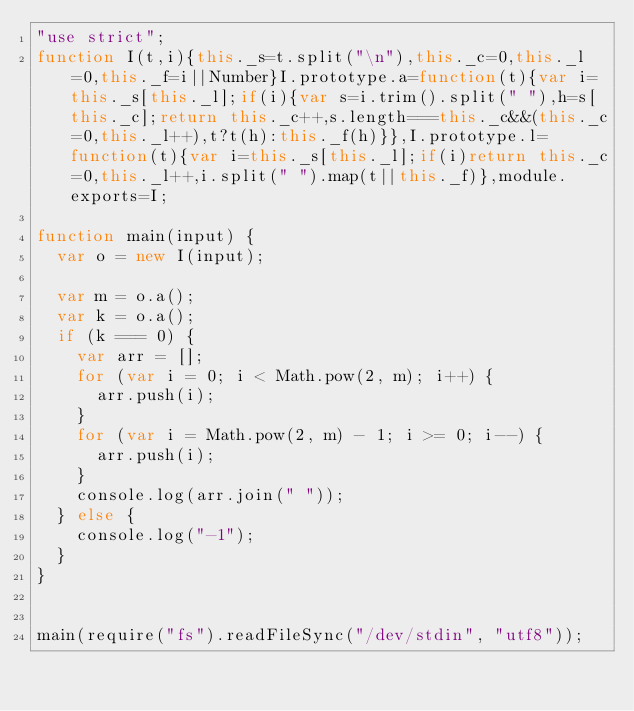<code> <loc_0><loc_0><loc_500><loc_500><_JavaScript_>"use strict";
function I(t,i){this._s=t.split("\n"),this._c=0,this._l=0,this._f=i||Number}I.prototype.a=function(t){var i=this._s[this._l];if(i){var s=i.trim().split(" "),h=s[this._c];return this._c++,s.length===this._c&&(this._c=0,this._l++),t?t(h):this._f(h)}},I.prototype.l=function(t){var i=this._s[this._l];if(i)return this._c=0,this._l++,i.split(" ").map(t||this._f)},module.exports=I;

function main(input) {
  var o = new I(input);

  var m = o.a();
  var k = o.a();
  if (k === 0) {
    var arr = [];
    for (var i = 0; i < Math.pow(2, m); i++) {
      arr.push(i);
    }
    for (var i = Math.pow(2, m) - 1; i >= 0; i--) {
      arr.push(i);
    }
    console.log(arr.join(" "));
  } else {
    console.log("-1");
  }
}


main(require("fs").readFileSync("/dev/stdin", "utf8"));
</code> 